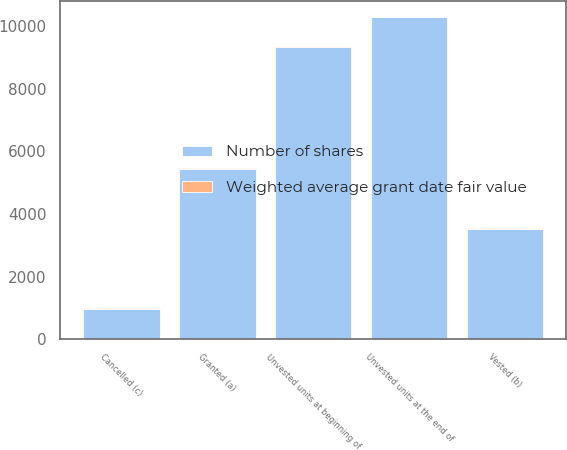Convert chart to OTSL. <chart><loc_0><loc_0><loc_500><loc_500><stacked_bar_chart><ecel><fcel>Unvested units at beginning of<fcel>Granted (a)<fcel>Vested (b)<fcel>Cancelled (c)<fcel>Unvested units at the end of<nl><fcel>Number of shares<fcel>9341<fcel>5445<fcel>3534<fcel>972<fcel>10280<nl><fcel>Weighted average grant date fair value<fcel>14.54<fcel>12.98<fcel>14.72<fcel>14.02<fcel>13.7<nl></chart> 